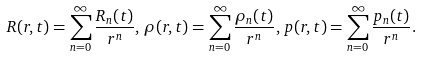Convert formula to latex. <formula><loc_0><loc_0><loc_500><loc_500>R ( r , t ) = \sum _ { n = 0 } ^ { \infty } \frac { R _ { n } ( t ) } { r ^ { n } } , \, \rho ( r , t ) = \sum _ { n = 0 } ^ { \infty } \frac { \rho _ { n } ( t ) } { r ^ { n } } , \, p ( r , t ) = \sum _ { n = 0 } ^ { \infty } \frac { p _ { n } ( t ) } { r ^ { n } } .</formula> 